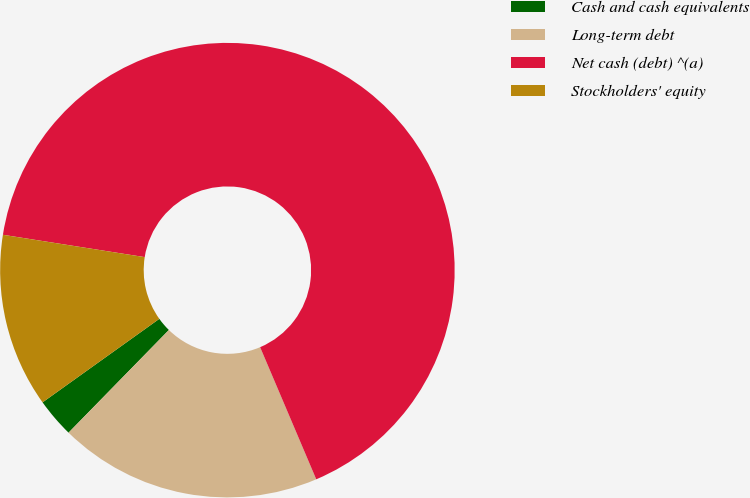Convert chart to OTSL. <chart><loc_0><loc_0><loc_500><loc_500><pie_chart><fcel>Cash and cash equivalents<fcel>Long-term debt<fcel>Net cash (debt) ^(a)<fcel>Stockholders' equity<nl><fcel>2.8%<fcel>18.71%<fcel>66.12%<fcel>12.37%<nl></chart> 